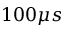<formula> <loc_0><loc_0><loc_500><loc_500>1 0 0 \mu s</formula> 